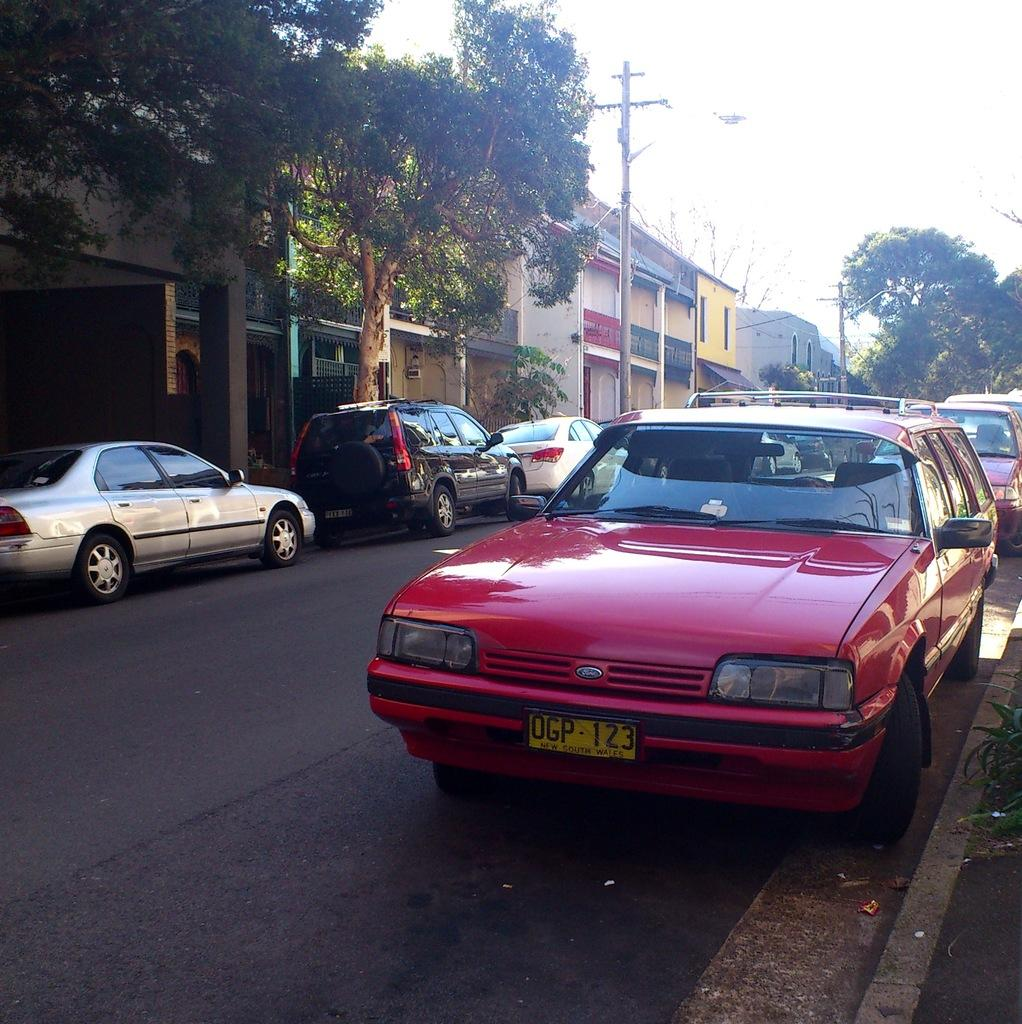What can be seen on both sides of the road in the image? There are cars parked on either side of the road. What colors are the cars in the image? The cars are red, black, and white in color. What is visible in the background of the image? There are trees, houses, and the sky visible in the background of the image. What type of oil is being used to lubricate the trees in the background? There is no indication in the image that the trees are being lubricated with oil, and therefore no such activity can be observed. 